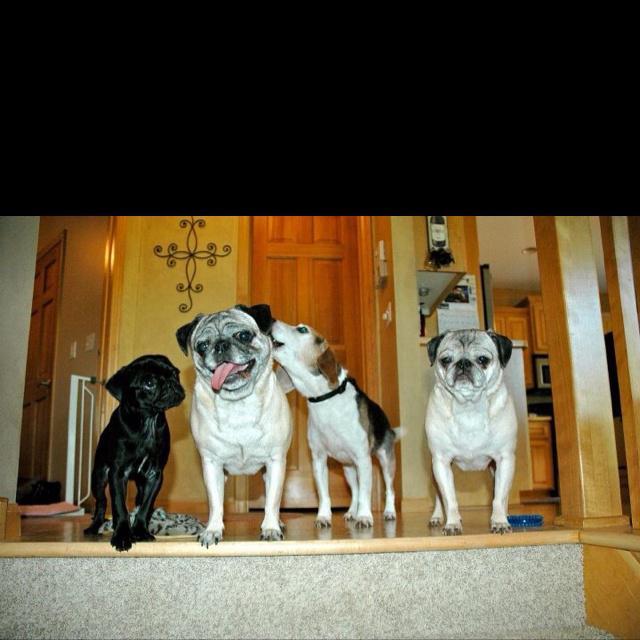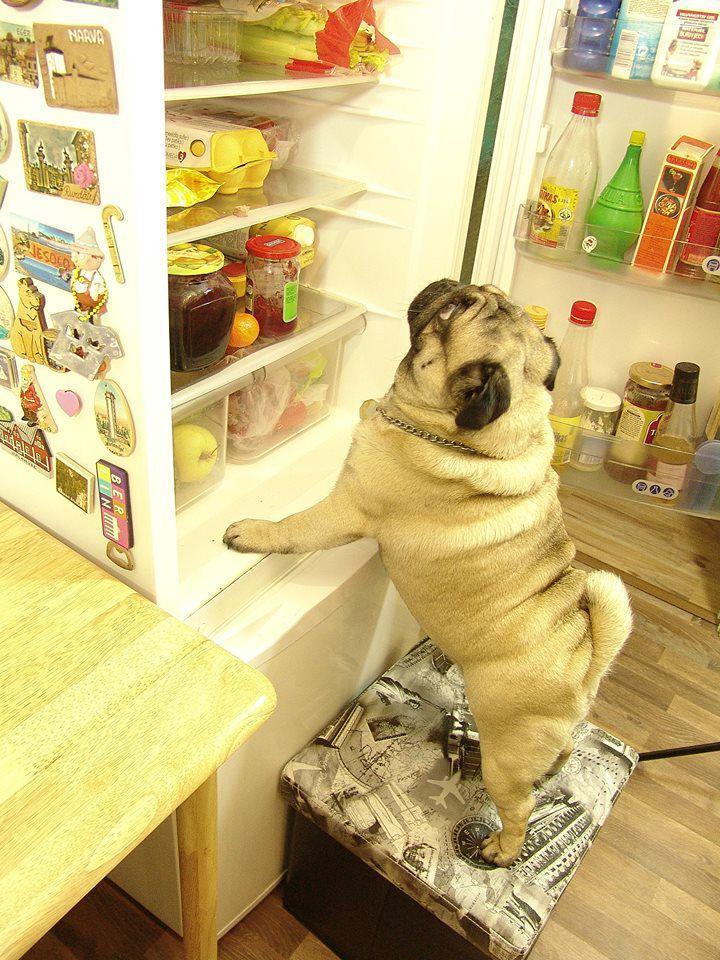The first image is the image on the left, the second image is the image on the right. For the images displayed, is the sentence "An image shows exactly one living pug that is sitting." factually correct? Answer yes or no. No. 